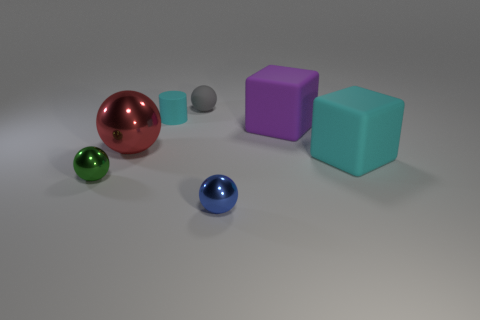Subtract all small gray balls. How many balls are left? 3 Add 3 big green metal cylinders. How many objects exist? 10 Subtract all cyan cubes. How many cubes are left? 1 Subtract all cylinders. How many objects are left? 6 Subtract all cyan spheres. Subtract all gray cylinders. How many spheres are left? 4 Subtract all blue blocks. How many green balls are left? 1 Subtract all cubes. Subtract all green metal cylinders. How many objects are left? 5 Add 4 green balls. How many green balls are left? 5 Add 5 big yellow rubber cubes. How many big yellow rubber cubes exist? 5 Subtract 0 yellow cylinders. How many objects are left? 7 